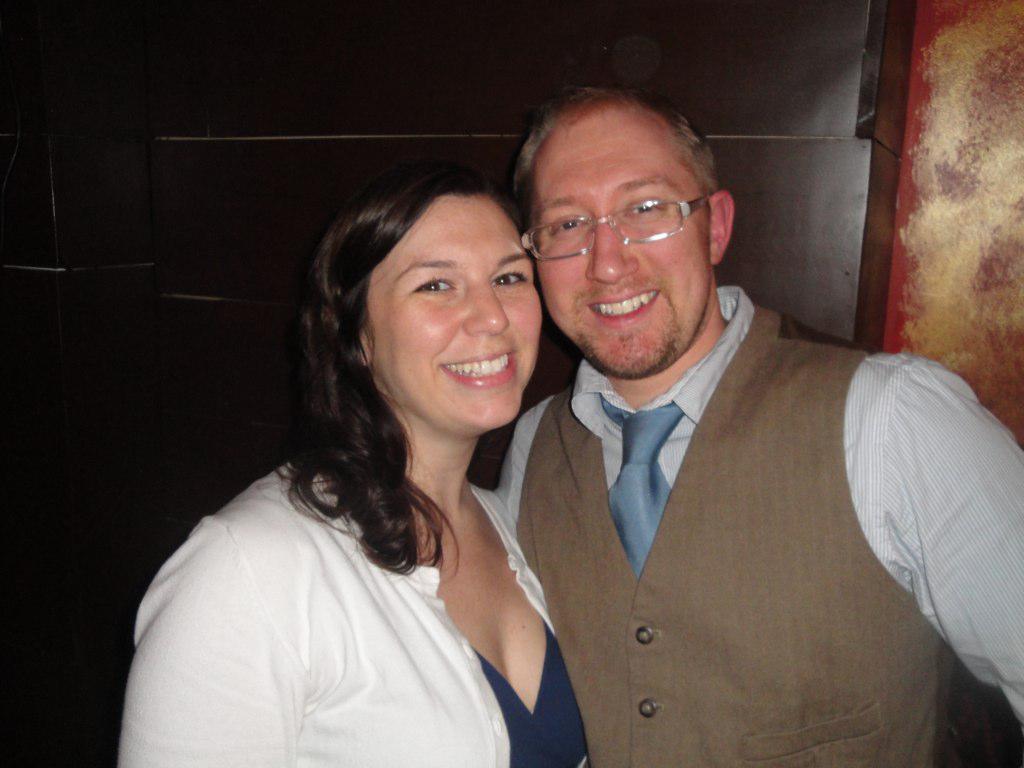Please provide a concise description of this image. In this picture we can observe a couple. Both of them was smiling. One of them was wearing white color dress and the other was a man wearing a brown color coat. In the background there is a wall. 